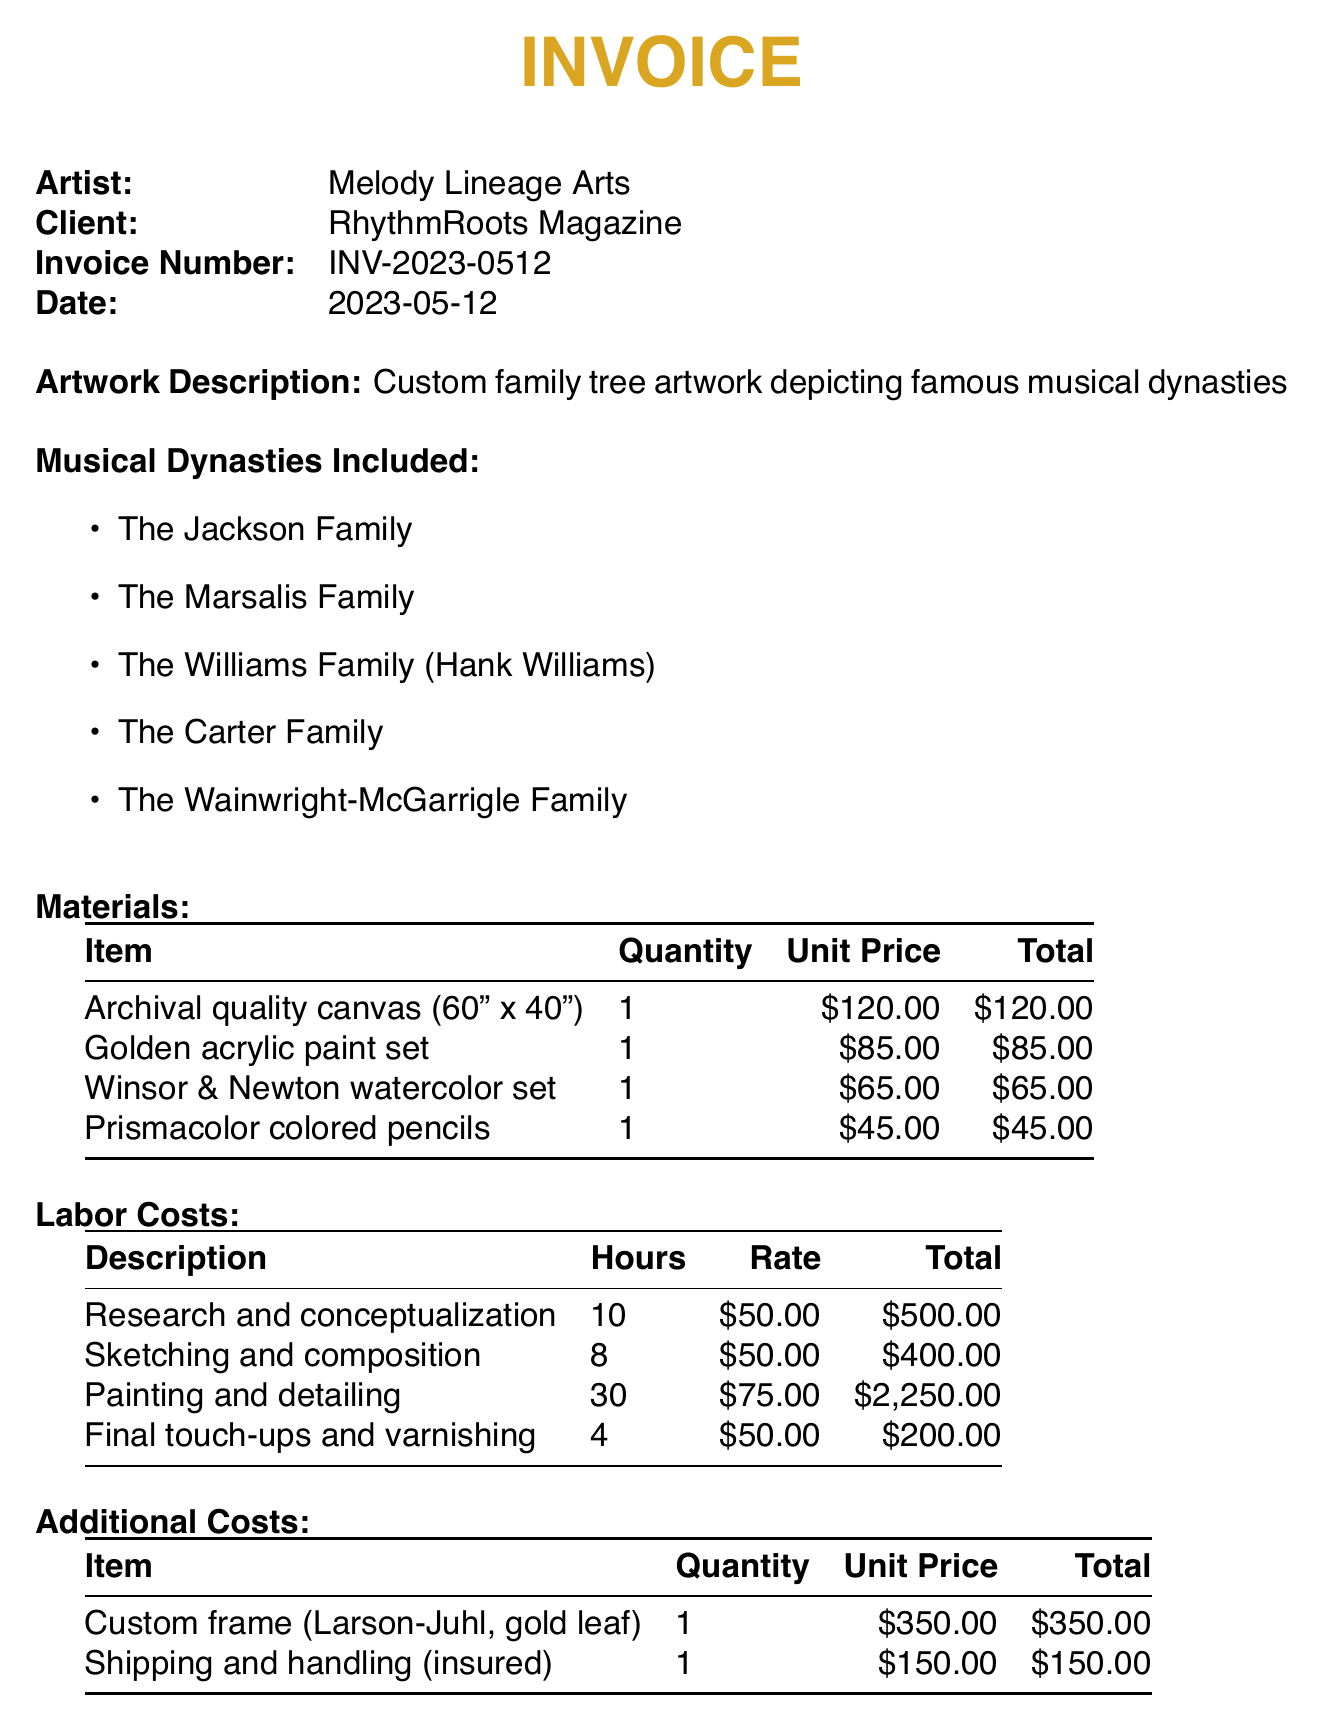What is the artist's name? The artist's name is listed at the top of the invoice details section.
Answer: Melody Lineage Arts What is the invoice number? The invoice number is specified in the invoice details.
Answer: INV-2023-0512 How many musical dynasties are included in the artwork? The number of musical dynasties is indicated in the list provided in the document.
Answer: Five What is the unit price of the archival quality canvas? The unit price for the archival quality canvas is detailed in the materials section.
Answer: $120.00 What was the total cost for painting and detailing? The total cost for painting and detailing is presented in the labor costs table.
Answer: $2,250.00 What is the total due amount on the invoice? The total amount due is provided at the end of the document.
Answer: $4,165.00 Which family is associated with Hank Williams? The document lists multiple families, including Hank Williams.
Answer: The Williams Family What item represents an additional cost for custom framing? The specific item for framing is detailed in the additional costs section.
Answer: Custom frame (Larson-Juhl, gold leaf) How many hours were spent on research and conceptualization? The total hours for research and conceptualization are noted in the labor costs section.
Answer: 10 